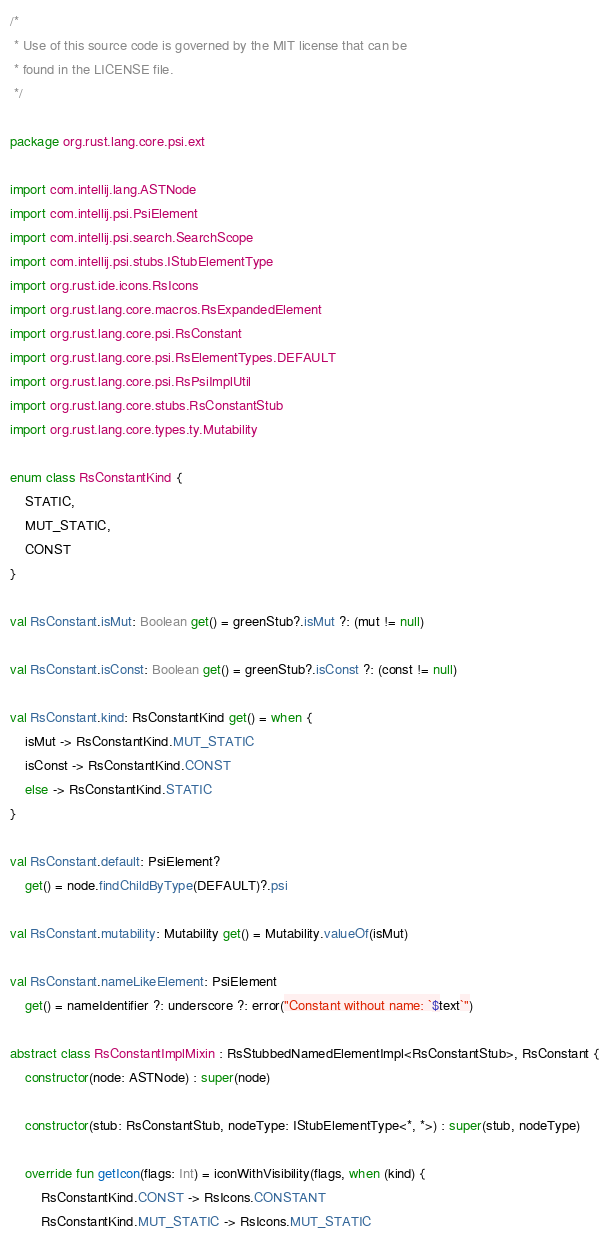<code> <loc_0><loc_0><loc_500><loc_500><_Kotlin_>/*
 * Use of this source code is governed by the MIT license that can be
 * found in the LICENSE file.
 */

package org.rust.lang.core.psi.ext

import com.intellij.lang.ASTNode
import com.intellij.psi.PsiElement
import com.intellij.psi.search.SearchScope
import com.intellij.psi.stubs.IStubElementType
import org.rust.ide.icons.RsIcons
import org.rust.lang.core.macros.RsExpandedElement
import org.rust.lang.core.psi.RsConstant
import org.rust.lang.core.psi.RsElementTypes.DEFAULT
import org.rust.lang.core.psi.RsPsiImplUtil
import org.rust.lang.core.stubs.RsConstantStub
import org.rust.lang.core.types.ty.Mutability

enum class RsConstantKind {
    STATIC,
    MUT_STATIC,
    CONST
}

val RsConstant.isMut: Boolean get() = greenStub?.isMut ?: (mut != null)

val RsConstant.isConst: Boolean get() = greenStub?.isConst ?: (const != null)

val RsConstant.kind: RsConstantKind get() = when {
    isMut -> RsConstantKind.MUT_STATIC
    isConst -> RsConstantKind.CONST
    else -> RsConstantKind.STATIC
}

val RsConstant.default: PsiElement?
    get() = node.findChildByType(DEFAULT)?.psi

val RsConstant.mutability: Mutability get() = Mutability.valueOf(isMut)

val RsConstant.nameLikeElement: PsiElement
    get() = nameIdentifier ?: underscore ?: error("Constant without name: `$text`")

abstract class RsConstantImplMixin : RsStubbedNamedElementImpl<RsConstantStub>, RsConstant {
    constructor(node: ASTNode) : super(node)

    constructor(stub: RsConstantStub, nodeType: IStubElementType<*, *>) : super(stub, nodeType)

    override fun getIcon(flags: Int) = iconWithVisibility(flags, when (kind) {
        RsConstantKind.CONST -> RsIcons.CONSTANT
        RsConstantKind.MUT_STATIC -> RsIcons.MUT_STATIC</code> 